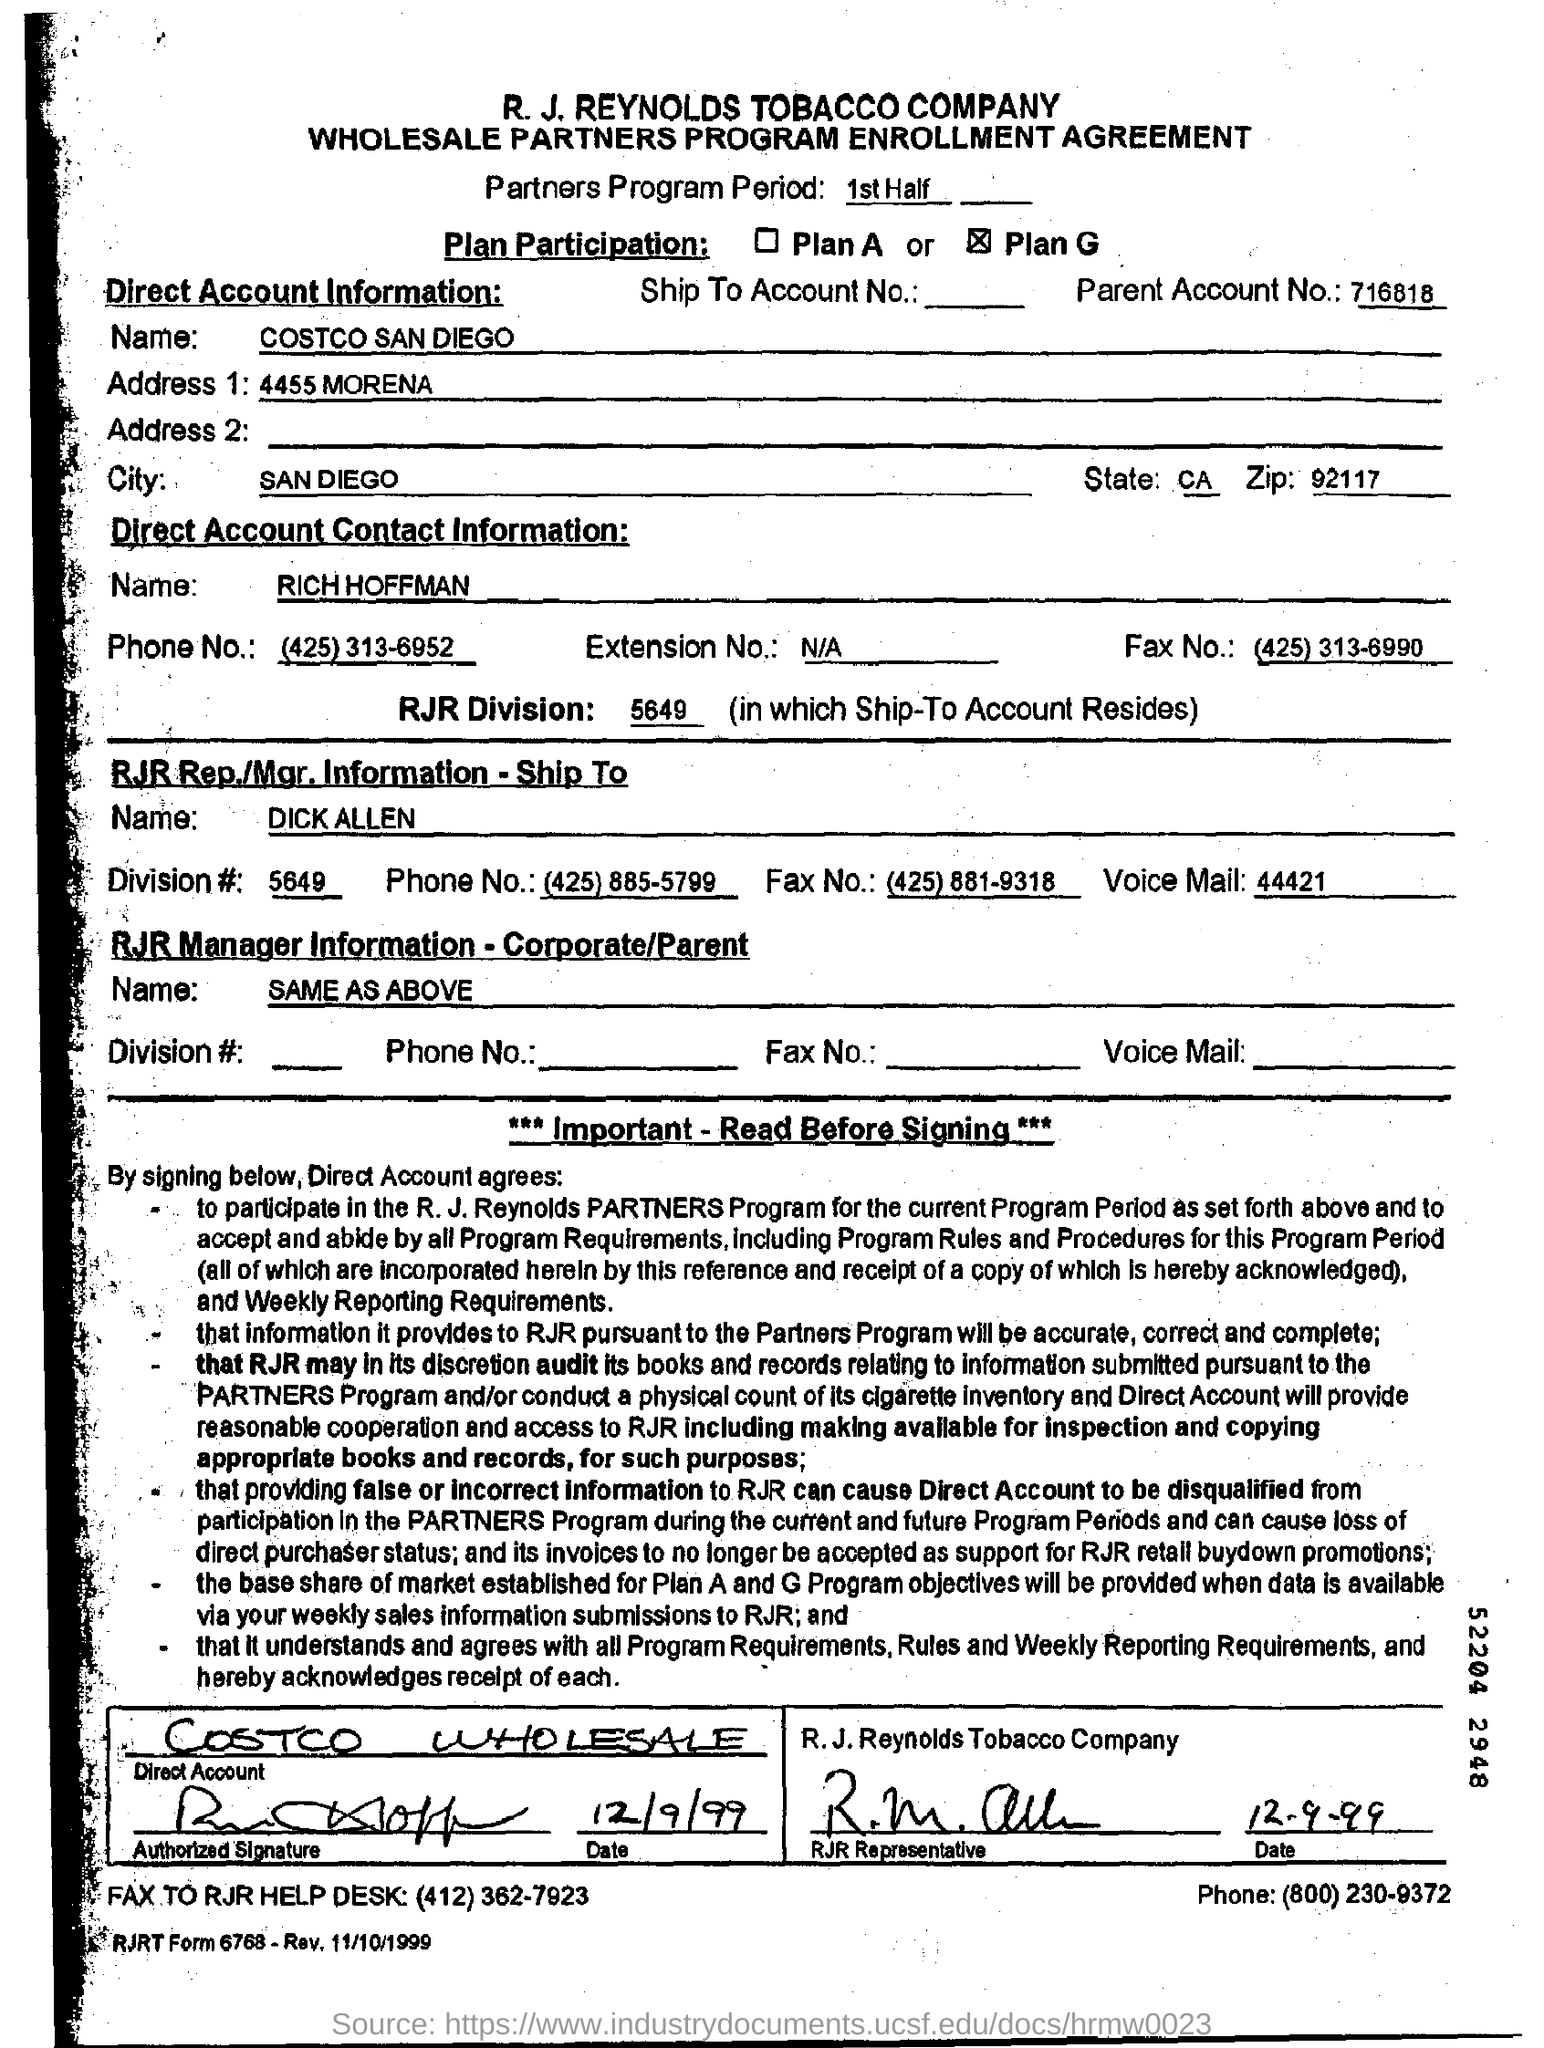What is the Company Name ?
Your answer should be very brief. R. J. Reynolds Tobacco Company. What is the Parent account no?
Ensure brevity in your answer.  716818. What is the Parent Account Number ?
Ensure brevity in your answer.  716818. What is the RJR Division Number ?
Provide a succinct answer. 5649. What is the Zip Code Number ?
Provide a succinct answer. 92117. 